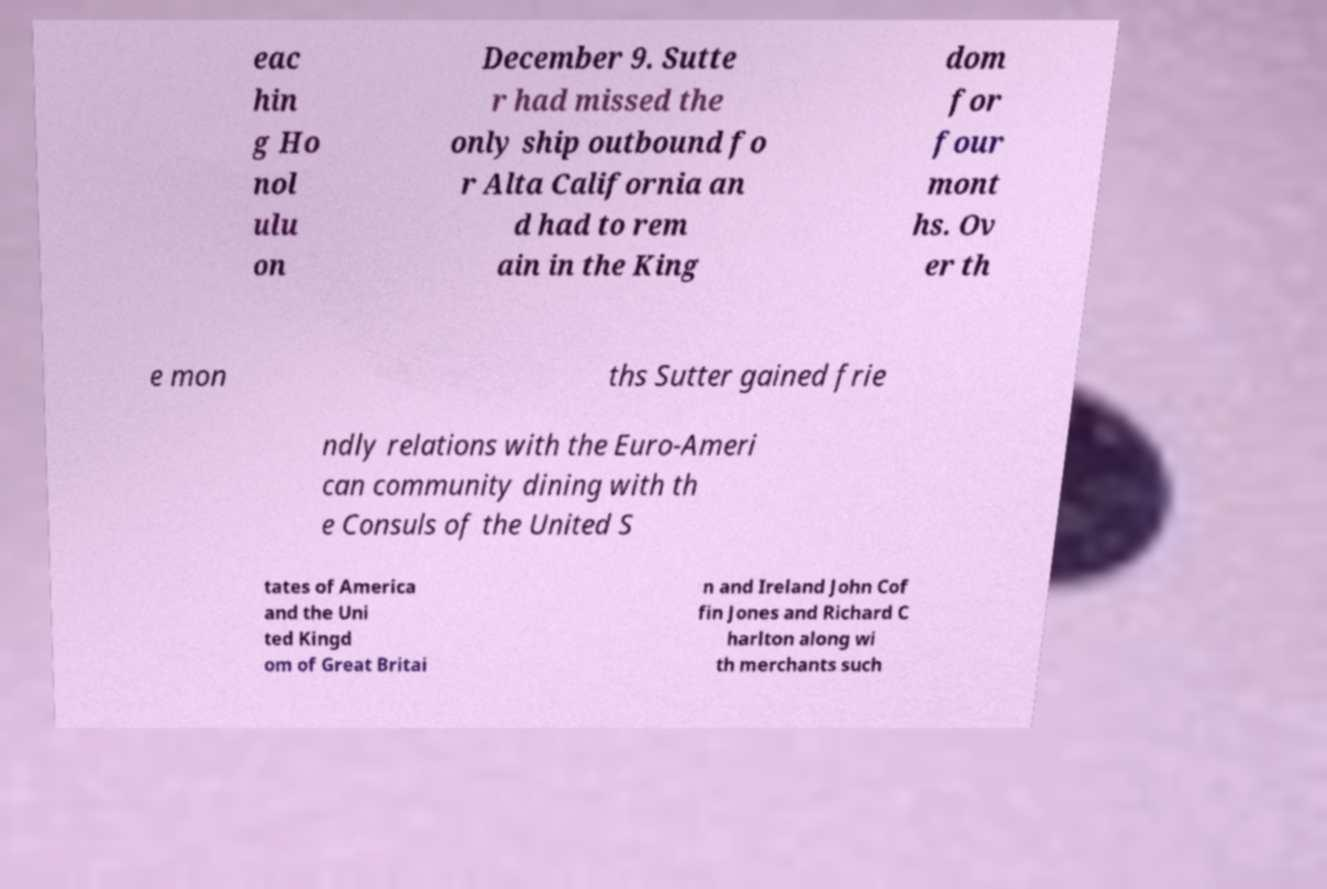Can you read and provide the text displayed in the image?This photo seems to have some interesting text. Can you extract and type it out for me? eac hin g Ho nol ulu on December 9. Sutte r had missed the only ship outbound fo r Alta California an d had to rem ain in the King dom for four mont hs. Ov er th e mon ths Sutter gained frie ndly relations with the Euro-Ameri can community dining with th e Consuls of the United S tates of America and the Uni ted Kingd om of Great Britai n and Ireland John Cof fin Jones and Richard C harlton along wi th merchants such 